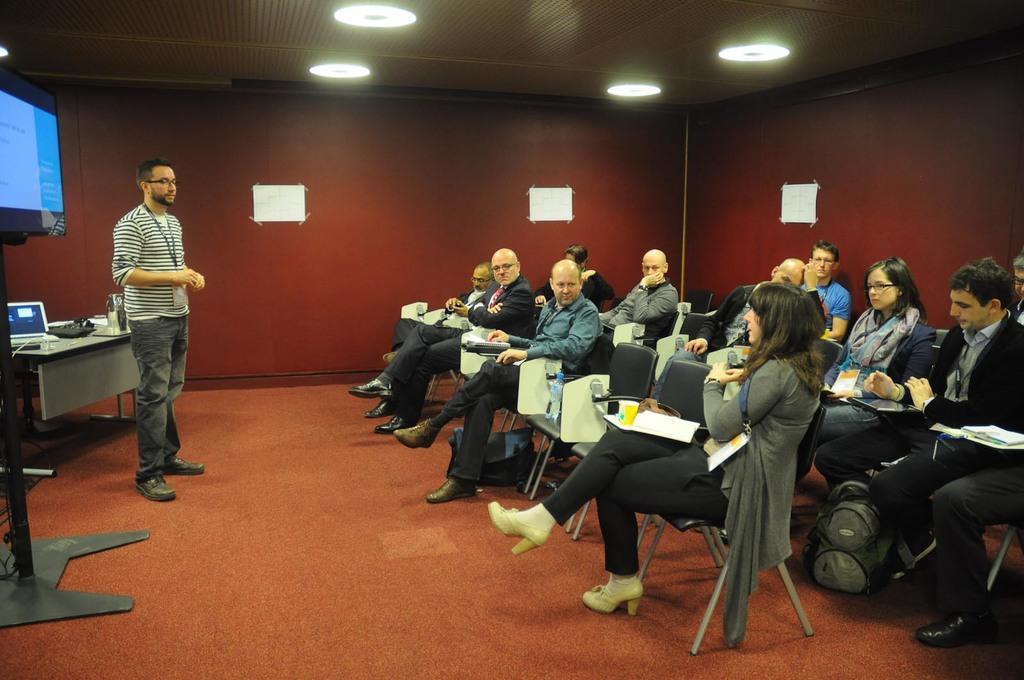Describe this image in one or two sentences. In this image I can see number of persons are siting on chairs which are black and white in color and I can see few papers in front of them. I can see a bag on the brown colored floor. To the left side of the image I can see a person standing, a screen, a table and on the table I can see a laptop and few other objects. In the background I can see the maroon colored wall, the ceiling and few lights to the ceiling. 